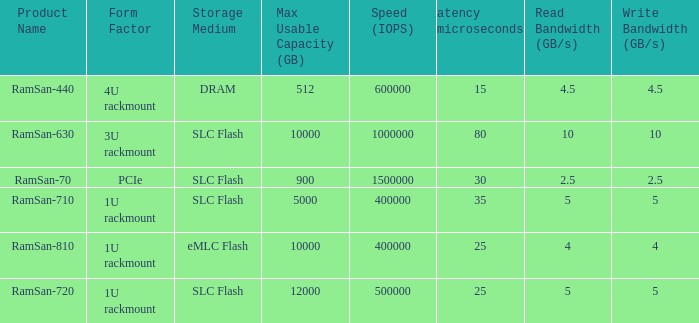List the range distroration for the ramsan-630 3U rackmount. 